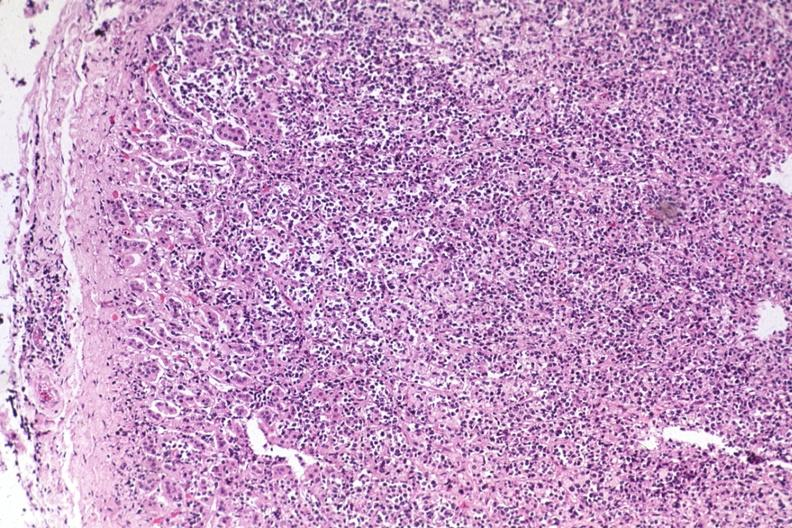does lymphangiomatosis generalized show diffuse infiltrate?
Answer the question using a single word or phrase. No 